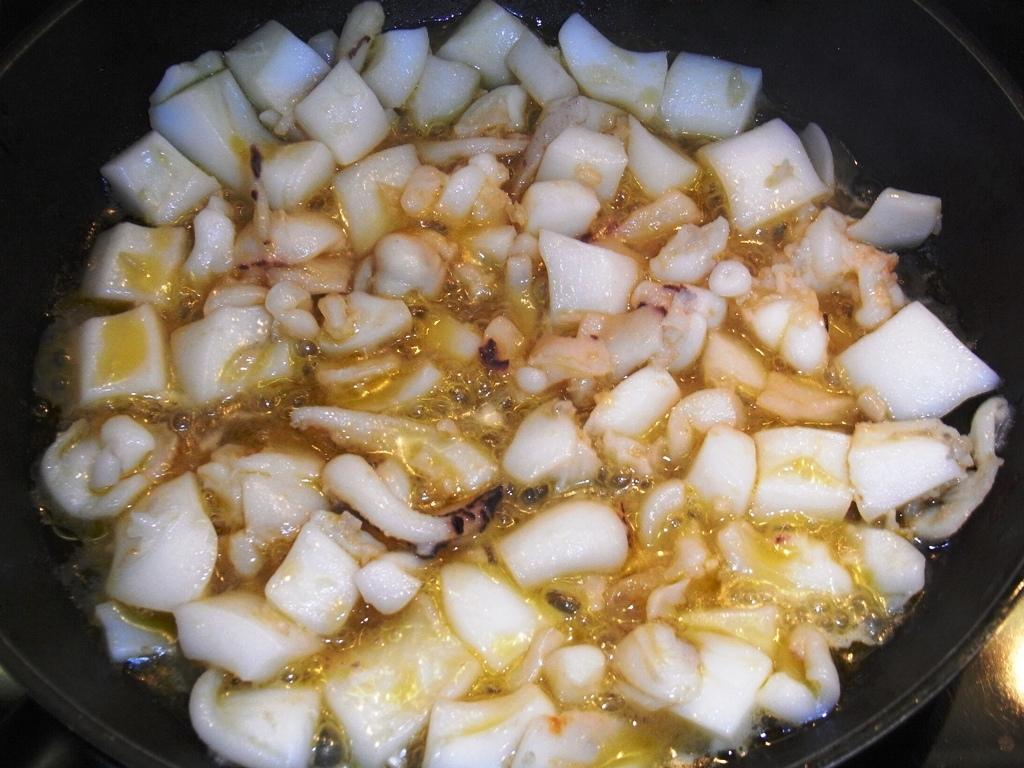What is present in the image? There is a bowl in the image. What is inside the bowl? The bowl contains a food item. Are there any thrilling elements present in the image? There is no indication of any thrilling elements in the image; it simply contains a bowl with a food item. 